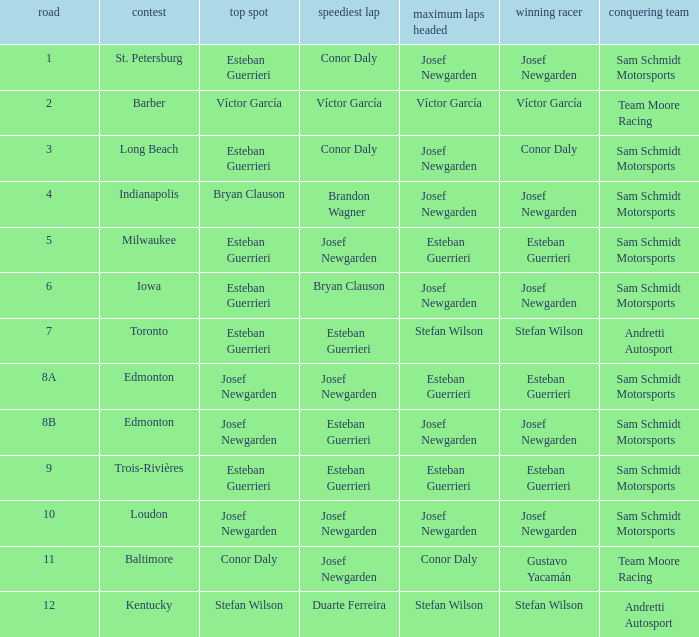Who had the fastest lap(s) when stefan wilson had the pole? Duarte Ferreira. Would you be able to parse every entry in this table? {'header': ['road', 'contest', 'top spot', 'speediest lap', 'maximum laps headed', 'winning racer', 'conquering team'], 'rows': [['1', 'St. Petersburg', 'Esteban Guerrieri', 'Conor Daly', 'Josef Newgarden', 'Josef Newgarden', 'Sam Schmidt Motorsports'], ['2', 'Barber', 'Víctor García', 'Víctor García', 'Víctor García', 'Víctor García', 'Team Moore Racing'], ['3', 'Long Beach', 'Esteban Guerrieri', 'Conor Daly', 'Josef Newgarden', 'Conor Daly', 'Sam Schmidt Motorsports'], ['4', 'Indianapolis', 'Bryan Clauson', 'Brandon Wagner', 'Josef Newgarden', 'Josef Newgarden', 'Sam Schmidt Motorsports'], ['5', 'Milwaukee', 'Esteban Guerrieri', 'Josef Newgarden', 'Esteban Guerrieri', 'Esteban Guerrieri', 'Sam Schmidt Motorsports'], ['6', 'Iowa', 'Esteban Guerrieri', 'Bryan Clauson', 'Josef Newgarden', 'Josef Newgarden', 'Sam Schmidt Motorsports'], ['7', 'Toronto', 'Esteban Guerrieri', 'Esteban Guerrieri', 'Stefan Wilson', 'Stefan Wilson', 'Andretti Autosport'], ['8A', 'Edmonton', 'Josef Newgarden', 'Josef Newgarden', 'Esteban Guerrieri', 'Esteban Guerrieri', 'Sam Schmidt Motorsports'], ['8B', 'Edmonton', 'Josef Newgarden', 'Esteban Guerrieri', 'Josef Newgarden', 'Josef Newgarden', 'Sam Schmidt Motorsports'], ['9', 'Trois-Rivières', 'Esteban Guerrieri', 'Esteban Guerrieri', 'Esteban Guerrieri', 'Esteban Guerrieri', 'Sam Schmidt Motorsports'], ['10', 'Loudon', 'Josef Newgarden', 'Josef Newgarden', 'Josef Newgarden', 'Josef Newgarden', 'Sam Schmidt Motorsports'], ['11', 'Baltimore', 'Conor Daly', 'Josef Newgarden', 'Conor Daly', 'Gustavo Yacamán', 'Team Moore Racing'], ['12', 'Kentucky', 'Stefan Wilson', 'Duarte Ferreira', 'Stefan Wilson', 'Stefan Wilson', 'Andretti Autosport']]} 